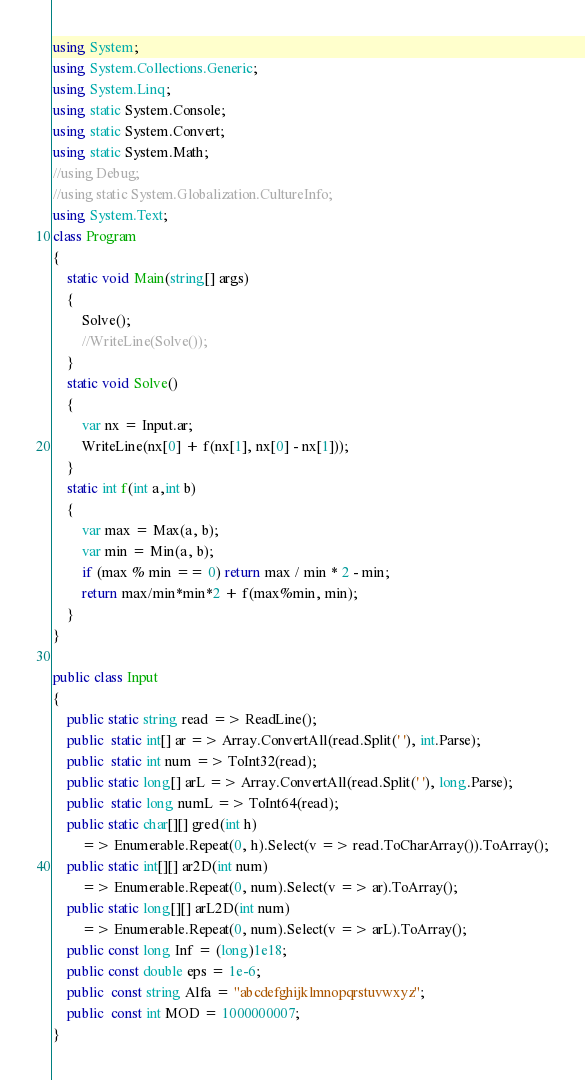Convert code to text. <code><loc_0><loc_0><loc_500><loc_500><_C#_>using System;
using System.Collections.Generic;
using System.Linq;
using static System.Console;
using static System.Convert;
using static System.Math;
//using Debug;
//using static System.Globalization.CultureInfo;
using System.Text;
class Program
{
    static void Main(string[] args)
    {
        Solve();
        //WriteLine(Solve());
    }
    static void Solve()
    {
        var nx = Input.ar;
        WriteLine(nx[0] + f(nx[1], nx[0] - nx[1]));
    }
    static int f(int a,int b)
    {
        var max = Max(a, b);
        var min = Min(a, b);
        if (max % min == 0) return max / min * 2 - min;
        return max/min*min*2 + f(max%min, min);
    }
}

public class Input
{
    public static string read => ReadLine();
    public  static int[] ar => Array.ConvertAll(read.Split(' '), int.Parse);
    public  static int num => ToInt32(read);
    public static long[] arL => Array.ConvertAll(read.Split(' '), long.Parse);
    public  static long numL => ToInt64(read);
    public static char[][] gred(int h) 
        => Enumerable.Repeat(0, h).Select(v => read.ToCharArray()).ToArray();
    public static int[][] ar2D(int num)
        => Enumerable.Repeat(0, num).Select(v => ar).ToArray();
    public static long[][] arL2D(int num)
        => Enumerable.Repeat(0, num).Select(v => arL).ToArray();
    public const long Inf = (long)1e18;
    public const double eps = 1e-6;
    public  const string Alfa = "abcdefghijklmnopqrstuvwxyz";
    public  const int MOD = 1000000007;
}
</code> 